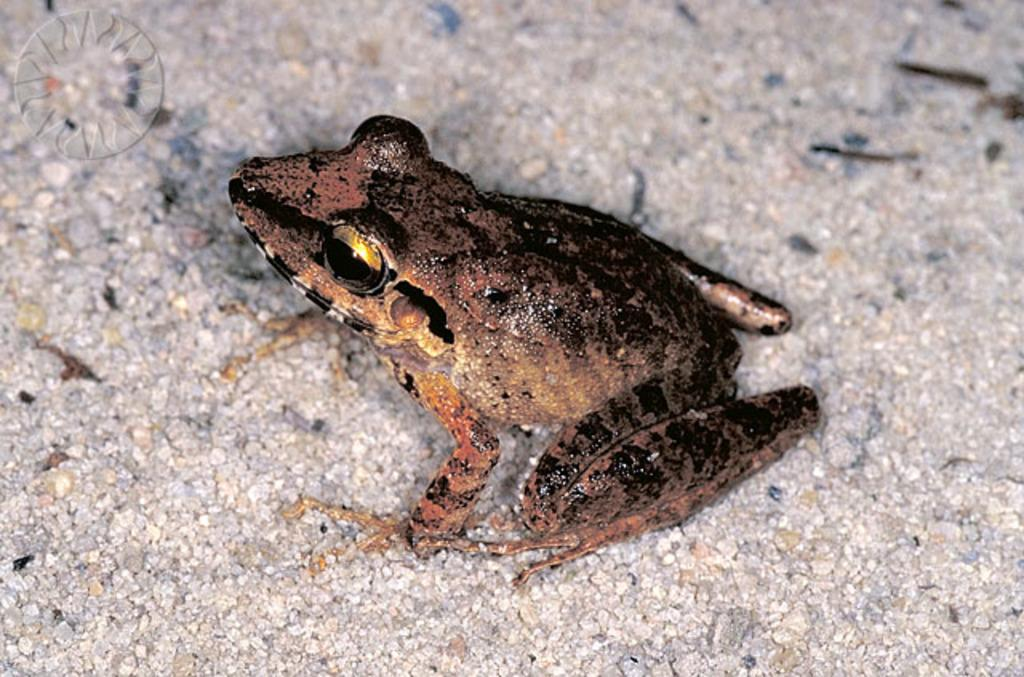What is the main subject in the center of the image? There is a frog in the center of the image. What type of record can be seen playing in the background of the image? There is no record or background music present in the image; it features a frog in the center. What part of the van is visible in the image? There is no van present in the image; it features a frog in the center. 